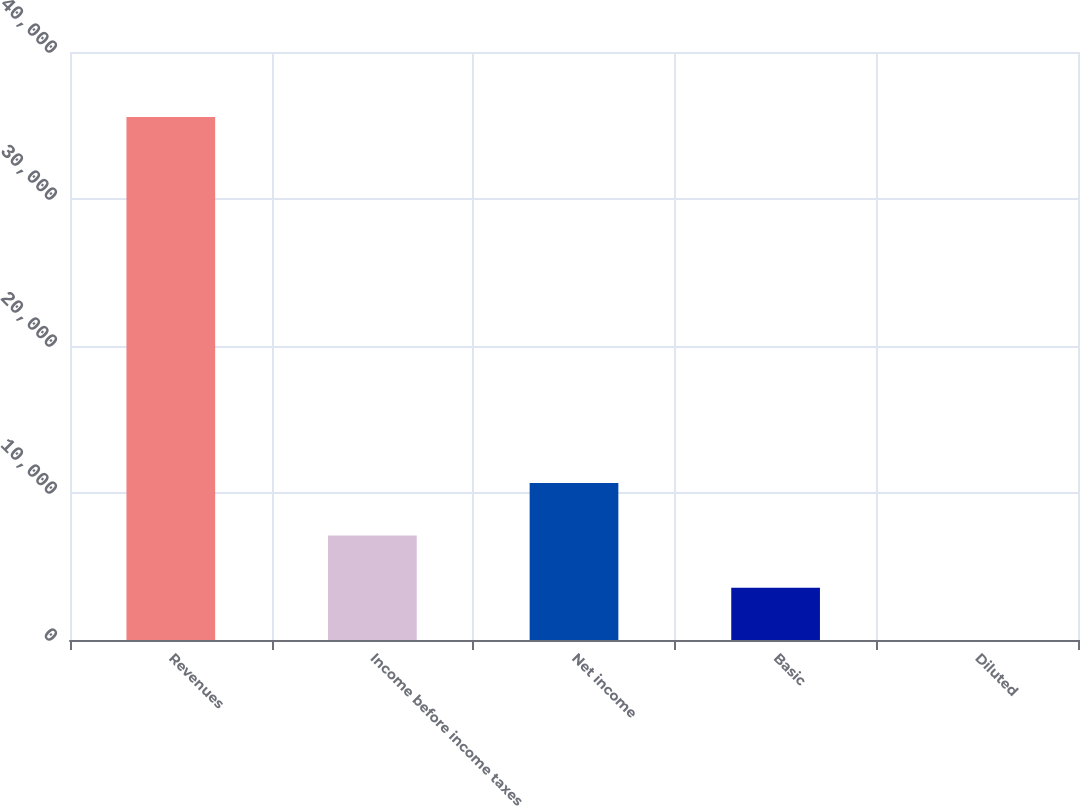Convert chart to OTSL. <chart><loc_0><loc_0><loc_500><loc_500><bar_chart><fcel>Revenues<fcel>Income before income taxes<fcel>Net income<fcel>Basic<fcel>Diluted<nl><fcel>35575<fcel>7115.6<fcel>10673<fcel>3558.17<fcel>0.74<nl></chart> 